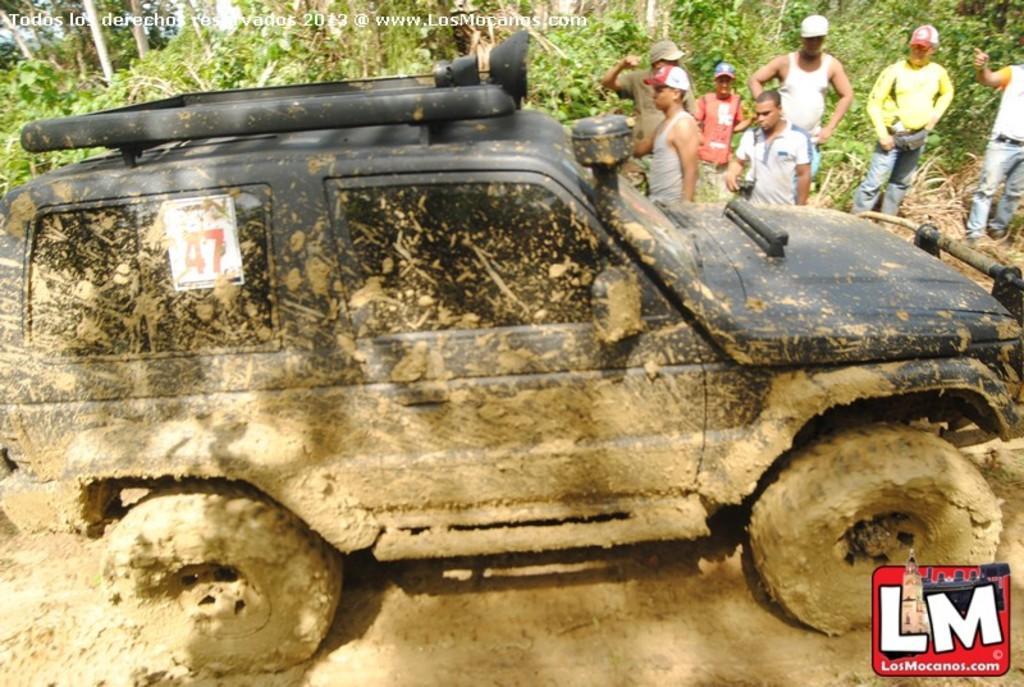Describe this image in one or two sentences. In the image in the center, we can see one car. In the bottom right side of the image, there is a logo. In the background we can see the trees and few people are standing. 